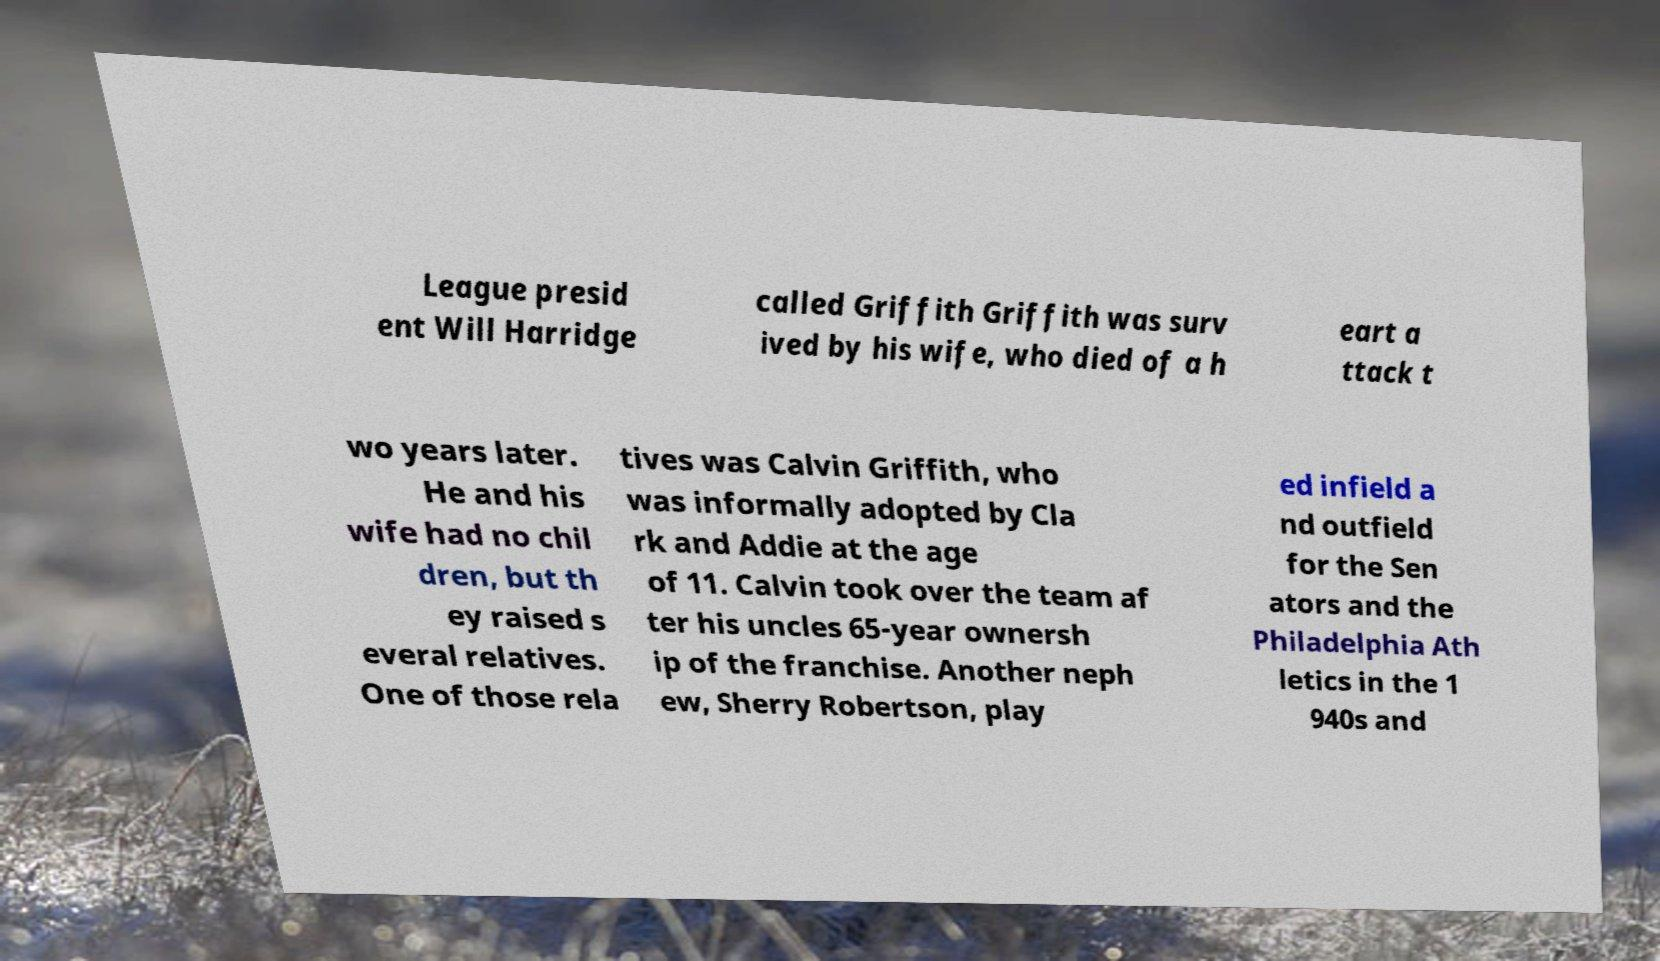Please read and relay the text visible in this image. What does it say? League presid ent Will Harridge called Griffith Griffith was surv ived by his wife, who died of a h eart a ttack t wo years later. He and his wife had no chil dren, but th ey raised s everal relatives. One of those rela tives was Calvin Griffith, who was informally adopted by Cla rk and Addie at the age of 11. Calvin took over the team af ter his uncles 65-year ownersh ip of the franchise. Another neph ew, Sherry Robertson, play ed infield a nd outfield for the Sen ators and the Philadelphia Ath letics in the 1 940s and 